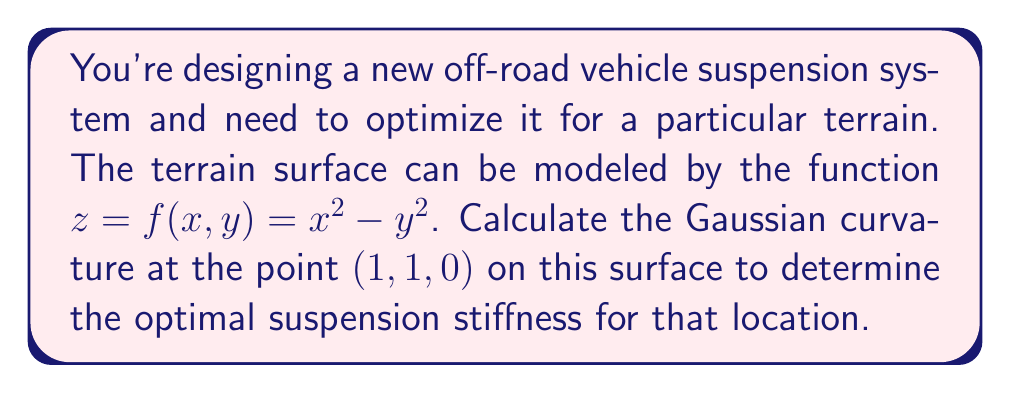Could you help me with this problem? To calculate the Gaussian curvature of the surface $z = f(x,y) = x^2 - y^2$ at the point (1, 1, 0), we'll follow these steps:

1) First, we need to calculate the partial derivatives:
   $f_x = 2x$
   $f_y = -2y$
   $f_{xx} = 2$
   $f_{yy} = -2$
   $f_{xy} = f_{yx} = 0$

2) Next, we'll calculate the coefficients of the first fundamental form:
   $E = 1 + f_x^2 = 1 + (2x)^2 = 1 + 4x^2$
   $F = f_x f_y = (2x)(-2y) = -4xy$
   $G = 1 + f_y^2 = 1 + (-2y)^2 = 1 + 4y^2$

3) Now, we'll calculate the coefficients of the second fundamental form:
   $L = \frac{f_{xx}}{\sqrt{1 + f_x^2 + f_y^2}} = \frac{2}{\sqrt{1 + 4x^2 + 4y^2}}$
   $M = \frac{f_{xy}}{\sqrt{1 + f_x^2 + f_y^2}} = 0$
   $N = \frac{f_{yy}}{\sqrt{1 + f_x^2 + f_y^2}} = \frac{-2}{\sqrt{1 + 4x^2 + 4y^2}}$

4) The Gaussian curvature is given by:
   $$K = \frac{LN - M^2}{EG - F^2}$$

5) Substituting the values at the point (1, 1, 0):
   $E = 1 + 4(1)^2 = 5$
   $F = -4(1)(1) = -4$
   $G = 1 + 4(1)^2 = 5$
   $L = \frac{2}{\sqrt{1 + 4(1)^2 + 4(1)^2}} = \frac{2}{3}$
   $M = 0$
   $N = \frac{-2}{\sqrt{1 + 4(1)^2 + 4(1)^2}} = -\frac{2}{3}$

6) Now we can calculate the Gaussian curvature:
   $$K = \frac{(\frac{2}{3})(-\frac{2}{3}) - 0^2}{(5)(5) - (-4)^2} = \frac{-\frac{4}{9}}{25 - 16} = -\frac{4}{81}$$
Answer: The Gaussian curvature at the point (1, 1, 0) is $-\frac{4}{81}$ or approximately $-0.0494$. 